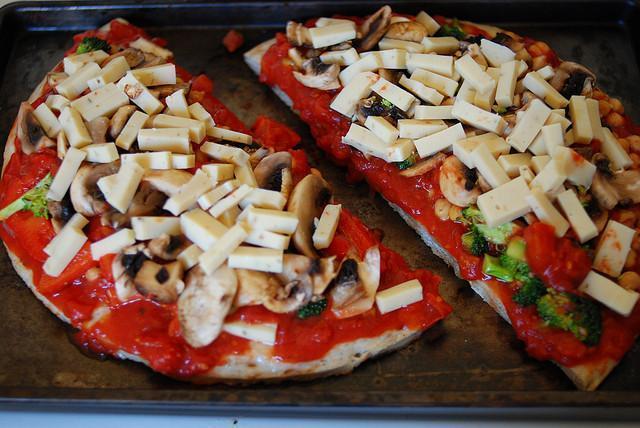How many broccolis can you see?
Give a very brief answer. 2. How many pizzas are there?
Give a very brief answer. 2. 